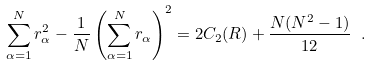<formula> <loc_0><loc_0><loc_500><loc_500>\sum _ { \alpha = 1 } ^ { N } r _ { \alpha } ^ { 2 } - \frac { 1 } { N } \left ( \sum _ { \alpha = 1 } ^ { N } r _ { \alpha } \right ) ^ { 2 } = 2 C _ { 2 } ( R ) + \frac { N ( N ^ { 2 } - 1 ) } { 1 2 } \ .</formula> 